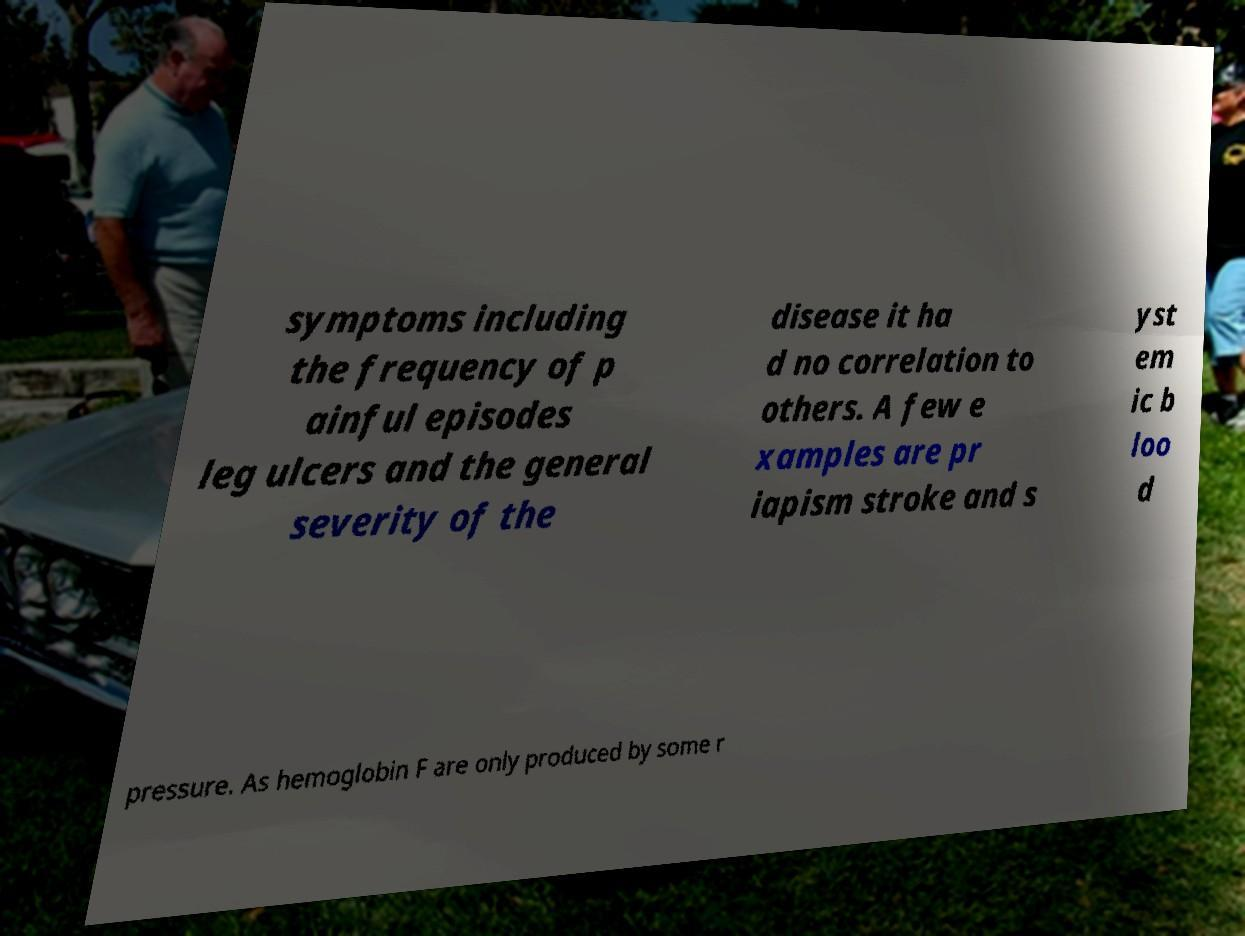Can you read and provide the text displayed in the image?This photo seems to have some interesting text. Can you extract and type it out for me? symptoms including the frequency of p ainful episodes leg ulcers and the general severity of the disease it ha d no correlation to others. A few e xamples are pr iapism stroke and s yst em ic b loo d pressure. As hemoglobin F are only produced by some r 